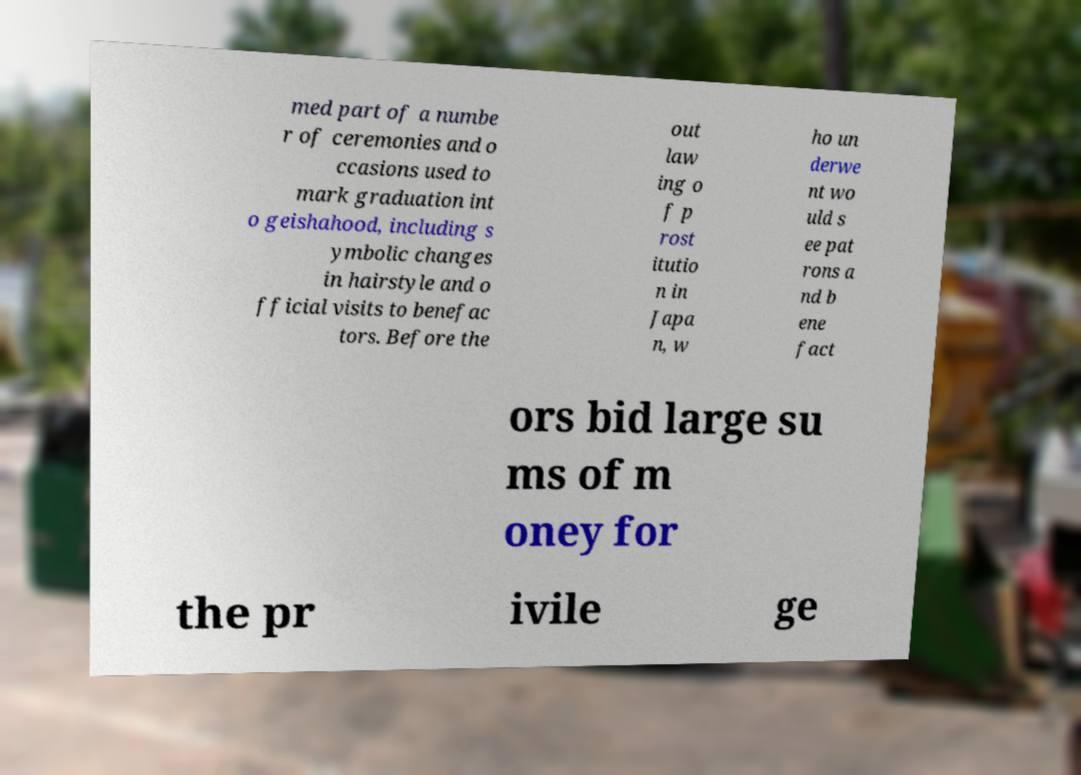Can you accurately transcribe the text from the provided image for me? med part of a numbe r of ceremonies and o ccasions used to mark graduation int o geishahood, including s ymbolic changes in hairstyle and o fficial visits to benefac tors. Before the out law ing o f p rost itutio n in Japa n, w ho un derwe nt wo uld s ee pat rons a nd b ene fact ors bid large su ms of m oney for the pr ivile ge 